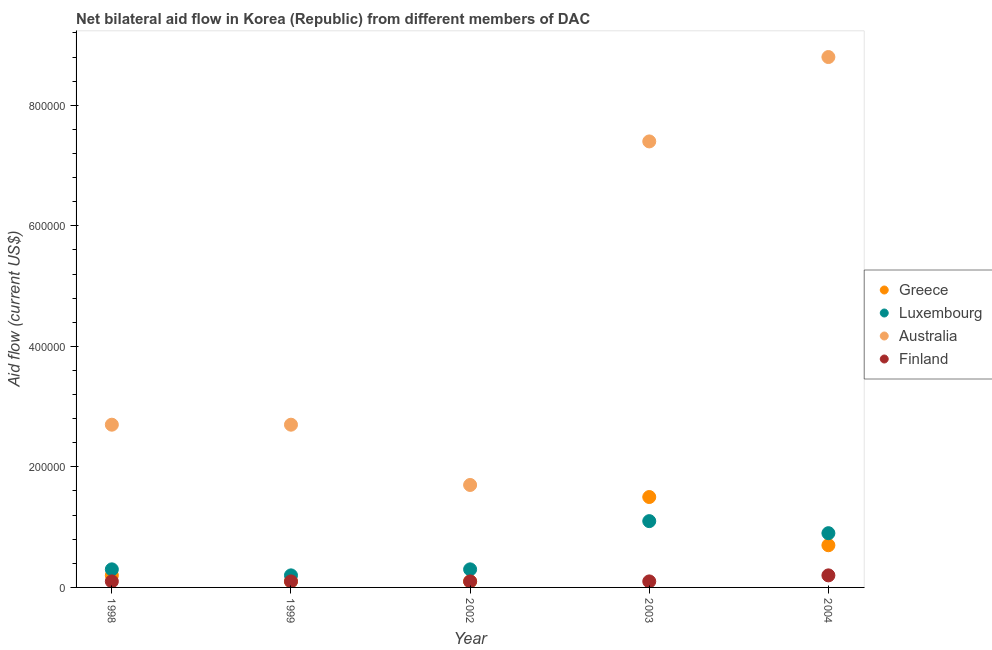How many different coloured dotlines are there?
Offer a very short reply. 4. Is the number of dotlines equal to the number of legend labels?
Keep it short and to the point. Yes. What is the amount of aid given by finland in 2004?
Offer a very short reply. 2.00e+04. Across all years, what is the maximum amount of aid given by luxembourg?
Provide a short and direct response. 1.10e+05. Across all years, what is the minimum amount of aid given by luxembourg?
Your answer should be compact. 2.00e+04. In which year was the amount of aid given by finland minimum?
Your answer should be very brief. 1998. What is the total amount of aid given by australia in the graph?
Make the answer very short. 2.33e+06. What is the difference between the amount of aid given by finland in 1998 and that in 2003?
Provide a short and direct response. 0. What is the difference between the amount of aid given by greece in 2002 and the amount of aid given by finland in 2004?
Provide a short and direct response. -10000. What is the average amount of aid given by luxembourg per year?
Your answer should be compact. 5.60e+04. In the year 2004, what is the difference between the amount of aid given by greece and amount of aid given by australia?
Your answer should be compact. -8.10e+05. What is the ratio of the amount of aid given by greece in 2003 to that in 2004?
Make the answer very short. 2.14. Is the amount of aid given by luxembourg in 1999 less than that in 2002?
Make the answer very short. Yes. What is the difference between the highest and the second highest amount of aid given by greece?
Your response must be concise. 8.00e+04. What is the difference between the highest and the lowest amount of aid given by australia?
Your answer should be very brief. 7.10e+05. Is it the case that in every year, the sum of the amount of aid given by greece and amount of aid given by luxembourg is greater than the amount of aid given by australia?
Your answer should be very brief. No. Does the amount of aid given by greece monotonically increase over the years?
Make the answer very short. No. Is the amount of aid given by greece strictly greater than the amount of aid given by luxembourg over the years?
Your answer should be compact. No. Is the amount of aid given by australia strictly less than the amount of aid given by luxembourg over the years?
Provide a short and direct response. No. What is the difference between two consecutive major ticks on the Y-axis?
Your response must be concise. 2.00e+05. Are the values on the major ticks of Y-axis written in scientific E-notation?
Offer a terse response. No. Does the graph contain grids?
Offer a terse response. No. Where does the legend appear in the graph?
Keep it short and to the point. Center right. What is the title of the graph?
Your answer should be very brief. Net bilateral aid flow in Korea (Republic) from different members of DAC. Does "Miscellaneous expenses" appear as one of the legend labels in the graph?
Make the answer very short. No. What is the label or title of the X-axis?
Keep it short and to the point. Year. What is the Aid flow (current US$) in Finland in 1998?
Provide a short and direct response. 10000. What is the Aid flow (current US$) of Luxembourg in 1999?
Ensure brevity in your answer.  2.00e+04. What is the Aid flow (current US$) of Australia in 1999?
Your response must be concise. 2.70e+05. What is the Aid flow (current US$) in Finland in 1999?
Offer a very short reply. 10000. What is the Aid flow (current US$) in Luxembourg in 2002?
Give a very brief answer. 3.00e+04. What is the Aid flow (current US$) of Australia in 2002?
Keep it short and to the point. 1.70e+05. What is the Aid flow (current US$) in Australia in 2003?
Give a very brief answer. 7.40e+05. What is the Aid flow (current US$) in Finland in 2003?
Your answer should be very brief. 10000. What is the Aid flow (current US$) of Greece in 2004?
Provide a short and direct response. 7.00e+04. What is the Aid flow (current US$) of Luxembourg in 2004?
Your response must be concise. 9.00e+04. What is the Aid flow (current US$) of Australia in 2004?
Your answer should be very brief. 8.80e+05. What is the Aid flow (current US$) of Finland in 2004?
Ensure brevity in your answer.  2.00e+04. Across all years, what is the maximum Aid flow (current US$) of Greece?
Offer a terse response. 1.50e+05. Across all years, what is the maximum Aid flow (current US$) of Luxembourg?
Provide a short and direct response. 1.10e+05. Across all years, what is the maximum Aid flow (current US$) of Australia?
Offer a terse response. 8.80e+05. Across all years, what is the minimum Aid flow (current US$) in Greece?
Your answer should be very brief. 10000. Across all years, what is the minimum Aid flow (current US$) in Luxembourg?
Make the answer very short. 2.00e+04. What is the total Aid flow (current US$) in Luxembourg in the graph?
Provide a short and direct response. 2.80e+05. What is the total Aid flow (current US$) of Australia in the graph?
Make the answer very short. 2.33e+06. What is the difference between the Aid flow (current US$) of Luxembourg in 1998 and that in 1999?
Ensure brevity in your answer.  10000. What is the difference between the Aid flow (current US$) in Australia in 1998 and that in 1999?
Your answer should be compact. 0. What is the difference between the Aid flow (current US$) of Australia in 1998 and that in 2002?
Make the answer very short. 1.00e+05. What is the difference between the Aid flow (current US$) of Luxembourg in 1998 and that in 2003?
Give a very brief answer. -8.00e+04. What is the difference between the Aid flow (current US$) in Australia in 1998 and that in 2003?
Give a very brief answer. -4.70e+05. What is the difference between the Aid flow (current US$) in Greece in 1998 and that in 2004?
Provide a succinct answer. -5.00e+04. What is the difference between the Aid flow (current US$) of Australia in 1998 and that in 2004?
Offer a very short reply. -6.10e+05. What is the difference between the Aid flow (current US$) in Greece in 1999 and that in 2002?
Keep it short and to the point. 0. What is the difference between the Aid flow (current US$) in Luxembourg in 1999 and that in 2002?
Provide a short and direct response. -10000. What is the difference between the Aid flow (current US$) in Australia in 1999 and that in 2002?
Make the answer very short. 1.00e+05. What is the difference between the Aid flow (current US$) in Finland in 1999 and that in 2002?
Give a very brief answer. 0. What is the difference between the Aid flow (current US$) of Greece in 1999 and that in 2003?
Offer a terse response. -1.40e+05. What is the difference between the Aid flow (current US$) of Luxembourg in 1999 and that in 2003?
Provide a succinct answer. -9.00e+04. What is the difference between the Aid flow (current US$) of Australia in 1999 and that in 2003?
Offer a very short reply. -4.70e+05. What is the difference between the Aid flow (current US$) in Greece in 1999 and that in 2004?
Offer a terse response. -6.00e+04. What is the difference between the Aid flow (current US$) in Australia in 1999 and that in 2004?
Provide a short and direct response. -6.10e+05. What is the difference between the Aid flow (current US$) in Finland in 1999 and that in 2004?
Offer a terse response. -10000. What is the difference between the Aid flow (current US$) of Luxembourg in 2002 and that in 2003?
Your answer should be very brief. -8.00e+04. What is the difference between the Aid flow (current US$) in Australia in 2002 and that in 2003?
Your answer should be very brief. -5.70e+05. What is the difference between the Aid flow (current US$) of Luxembourg in 2002 and that in 2004?
Offer a terse response. -6.00e+04. What is the difference between the Aid flow (current US$) of Australia in 2002 and that in 2004?
Make the answer very short. -7.10e+05. What is the difference between the Aid flow (current US$) of Finland in 2002 and that in 2004?
Keep it short and to the point. -10000. What is the difference between the Aid flow (current US$) in Greece in 2003 and that in 2004?
Make the answer very short. 8.00e+04. What is the difference between the Aid flow (current US$) of Luxembourg in 2003 and that in 2004?
Provide a short and direct response. 2.00e+04. What is the difference between the Aid flow (current US$) of Finland in 2003 and that in 2004?
Provide a short and direct response. -10000. What is the difference between the Aid flow (current US$) in Greece in 1998 and the Aid flow (current US$) in Luxembourg in 1999?
Provide a short and direct response. 0. What is the difference between the Aid flow (current US$) in Greece in 1998 and the Aid flow (current US$) in Australia in 1999?
Your answer should be compact. -2.50e+05. What is the difference between the Aid flow (current US$) in Greece in 1998 and the Aid flow (current US$) in Finland in 1999?
Keep it short and to the point. 10000. What is the difference between the Aid flow (current US$) in Luxembourg in 1998 and the Aid flow (current US$) in Australia in 1999?
Make the answer very short. -2.40e+05. What is the difference between the Aid flow (current US$) of Luxembourg in 1998 and the Aid flow (current US$) of Finland in 1999?
Make the answer very short. 2.00e+04. What is the difference between the Aid flow (current US$) of Australia in 1998 and the Aid flow (current US$) of Finland in 1999?
Make the answer very short. 2.60e+05. What is the difference between the Aid flow (current US$) in Greece in 1998 and the Aid flow (current US$) in Luxembourg in 2002?
Make the answer very short. -10000. What is the difference between the Aid flow (current US$) in Greece in 1998 and the Aid flow (current US$) in Finland in 2002?
Provide a succinct answer. 10000. What is the difference between the Aid flow (current US$) of Luxembourg in 1998 and the Aid flow (current US$) of Australia in 2002?
Your answer should be compact. -1.40e+05. What is the difference between the Aid flow (current US$) in Luxembourg in 1998 and the Aid flow (current US$) in Finland in 2002?
Provide a short and direct response. 2.00e+04. What is the difference between the Aid flow (current US$) of Greece in 1998 and the Aid flow (current US$) of Australia in 2003?
Keep it short and to the point. -7.20e+05. What is the difference between the Aid flow (current US$) of Luxembourg in 1998 and the Aid flow (current US$) of Australia in 2003?
Give a very brief answer. -7.10e+05. What is the difference between the Aid flow (current US$) of Australia in 1998 and the Aid flow (current US$) of Finland in 2003?
Offer a terse response. 2.60e+05. What is the difference between the Aid flow (current US$) in Greece in 1998 and the Aid flow (current US$) in Luxembourg in 2004?
Your response must be concise. -7.00e+04. What is the difference between the Aid flow (current US$) in Greece in 1998 and the Aid flow (current US$) in Australia in 2004?
Provide a succinct answer. -8.60e+05. What is the difference between the Aid flow (current US$) of Greece in 1998 and the Aid flow (current US$) of Finland in 2004?
Give a very brief answer. 0. What is the difference between the Aid flow (current US$) of Luxembourg in 1998 and the Aid flow (current US$) of Australia in 2004?
Offer a very short reply. -8.50e+05. What is the difference between the Aid flow (current US$) of Luxembourg in 1998 and the Aid flow (current US$) of Finland in 2004?
Offer a very short reply. 10000. What is the difference between the Aid flow (current US$) of Australia in 1998 and the Aid flow (current US$) of Finland in 2004?
Your answer should be compact. 2.50e+05. What is the difference between the Aid flow (current US$) of Greece in 1999 and the Aid flow (current US$) of Luxembourg in 2002?
Ensure brevity in your answer.  -2.00e+04. What is the difference between the Aid flow (current US$) in Greece in 1999 and the Aid flow (current US$) in Australia in 2002?
Your response must be concise. -1.60e+05. What is the difference between the Aid flow (current US$) of Luxembourg in 1999 and the Aid flow (current US$) of Finland in 2002?
Your answer should be compact. 10000. What is the difference between the Aid flow (current US$) in Greece in 1999 and the Aid flow (current US$) in Luxembourg in 2003?
Your answer should be compact. -1.00e+05. What is the difference between the Aid flow (current US$) in Greece in 1999 and the Aid flow (current US$) in Australia in 2003?
Offer a very short reply. -7.30e+05. What is the difference between the Aid flow (current US$) in Greece in 1999 and the Aid flow (current US$) in Finland in 2003?
Offer a terse response. 0. What is the difference between the Aid flow (current US$) of Luxembourg in 1999 and the Aid flow (current US$) of Australia in 2003?
Provide a short and direct response. -7.20e+05. What is the difference between the Aid flow (current US$) in Greece in 1999 and the Aid flow (current US$) in Luxembourg in 2004?
Provide a short and direct response. -8.00e+04. What is the difference between the Aid flow (current US$) of Greece in 1999 and the Aid flow (current US$) of Australia in 2004?
Ensure brevity in your answer.  -8.70e+05. What is the difference between the Aid flow (current US$) of Luxembourg in 1999 and the Aid flow (current US$) of Australia in 2004?
Provide a succinct answer. -8.60e+05. What is the difference between the Aid flow (current US$) of Greece in 2002 and the Aid flow (current US$) of Australia in 2003?
Make the answer very short. -7.30e+05. What is the difference between the Aid flow (current US$) of Greece in 2002 and the Aid flow (current US$) of Finland in 2003?
Provide a succinct answer. 0. What is the difference between the Aid flow (current US$) of Luxembourg in 2002 and the Aid flow (current US$) of Australia in 2003?
Ensure brevity in your answer.  -7.10e+05. What is the difference between the Aid flow (current US$) in Luxembourg in 2002 and the Aid flow (current US$) in Finland in 2003?
Offer a very short reply. 2.00e+04. What is the difference between the Aid flow (current US$) in Greece in 2002 and the Aid flow (current US$) in Luxembourg in 2004?
Provide a short and direct response. -8.00e+04. What is the difference between the Aid flow (current US$) of Greece in 2002 and the Aid flow (current US$) of Australia in 2004?
Offer a very short reply. -8.70e+05. What is the difference between the Aid flow (current US$) of Greece in 2002 and the Aid flow (current US$) of Finland in 2004?
Provide a short and direct response. -10000. What is the difference between the Aid flow (current US$) of Luxembourg in 2002 and the Aid flow (current US$) of Australia in 2004?
Keep it short and to the point. -8.50e+05. What is the difference between the Aid flow (current US$) of Greece in 2003 and the Aid flow (current US$) of Luxembourg in 2004?
Keep it short and to the point. 6.00e+04. What is the difference between the Aid flow (current US$) in Greece in 2003 and the Aid flow (current US$) in Australia in 2004?
Your answer should be compact. -7.30e+05. What is the difference between the Aid flow (current US$) of Greece in 2003 and the Aid flow (current US$) of Finland in 2004?
Provide a succinct answer. 1.30e+05. What is the difference between the Aid flow (current US$) of Luxembourg in 2003 and the Aid flow (current US$) of Australia in 2004?
Provide a succinct answer. -7.70e+05. What is the difference between the Aid flow (current US$) of Australia in 2003 and the Aid flow (current US$) of Finland in 2004?
Keep it short and to the point. 7.20e+05. What is the average Aid flow (current US$) of Greece per year?
Your answer should be very brief. 5.20e+04. What is the average Aid flow (current US$) in Luxembourg per year?
Your answer should be compact. 5.60e+04. What is the average Aid flow (current US$) in Australia per year?
Keep it short and to the point. 4.66e+05. What is the average Aid flow (current US$) of Finland per year?
Your answer should be compact. 1.20e+04. In the year 1998, what is the difference between the Aid flow (current US$) in Greece and Aid flow (current US$) in Luxembourg?
Your answer should be compact. -10000. In the year 1998, what is the difference between the Aid flow (current US$) of Greece and Aid flow (current US$) of Finland?
Your response must be concise. 10000. In the year 1998, what is the difference between the Aid flow (current US$) of Luxembourg and Aid flow (current US$) of Finland?
Offer a terse response. 2.00e+04. In the year 2002, what is the difference between the Aid flow (current US$) in Greece and Aid flow (current US$) in Luxembourg?
Offer a terse response. -2.00e+04. In the year 2002, what is the difference between the Aid flow (current US$) in Australia and Aid flow (current US$) in Finland?
Your answer should be compact. 1.60e+05. In the year 2003, what is the difference between the Aid flow (current US$) in Greece and Aid flow (current US$) in Australia?
Provide a short and direct response. -5.90e+05. In the year 2003, what is the difference between the Aid flow (current US$) of Luxembourg and Aid flow (current US$) of Australia?
Your answer should be compact. -6.30e+05. In the year 2003, what is the difference between the Aid flow (current US$) of Australia and Aid flow (current US$) of Finland?
Offer a very short reply. 7.30e+05. In the year 2004, what is the difference between the Aid flow (current US$) of Greece and Aid flow (current US$) of Luxembourg?
Ensure brevity in your answer.  -2.00e+04. In the year 2004, what is the difference between the Aid flow (current US$) in Greece and Aid flow (current US$) in Australia?
Make the answer very short. -8.10e+05. In the year 2004, what is the difference between the Aid flow (current US$) in Greece and Aid flow (current US$) in Finland?
Your answer should be very brief. 5.00e+04. In the year 2004, what is the difference between the Aid flow (current US$) of Luxembourg and Aid flow (current US$) of Australia?
Ensure brevity in your answer.  -7.90e+05. In the year 2004, what is the difference between the Aid flow (current US$) of Luxembourg and Aid flow (current US$) of Finland?
Your answer should be compact. 7.00e+04. In the year 2004, what is the difference between the Aid flow (current US$) of Australia and Aid flow (current US$) of Finland?
Your answer should be very brief. 8.60e+05. What is the ratio of the Aid flow (current US$) in Australia in 1998 to that in 1999?
Provide a short and direct response. 1. What is the ratio of the Aid flow (current US$) in Luxembourg in 1998 to that in 2002?
Provide a succinct answer. 1. What is the ratio of the Aid flow (current US$) in Australia in 1998 to that in 2002?
Ensure brevity in your answer.  1.59. What is the ratio of the Aid flow (current US$) of Finland in 1998 to that in 2002?
Your response must be concise. 1. What is the ratio of the Aid flow (current US$) of Greece in 1998 to that in 2003?
Your answer should be compact. 0.13. What is the ratio of the Aid flow (current US$) in Luxembourg in 1998 to that in 2003?
Provide a succinct answer. 0.27. What is the ratio of the Aid flow (current US$) in Australia in 1998 to that in 2003?
Offer a very short reply. 0.36. What is the ratio of the Aid flow (current US$) in Greece in 1998 to that in 2004?
Make the answer very short. 0.29. What is the ratio of the Aid flow (current US$) in Australia in 1998 to that in 2004?
Ensure brevity in your answer.  0.31. What is the ratio of the Aid flow (current US$) in Finland in 1998 to that in 2004?
Offer a terse response. 0.5. What is the ratio of the Aid flow (current US$) in Greece in 1999 to that in 2002?
Ensure brevity in your answer.  1. What is the ratio of the Aid flow (current US$) in Australia in 1999 to that in 2002?
Your answer should be very brief. 1.59. What is the ratio of the Aid flow (current US$) of Greece in 1999 to that in 2003?
Offer a very short reply. 0.07. What is the ratio of the Aid flow (current US$) in Luxembourg in 1999 to that in 2003?
Your answer should be compact. 0.18. What is the ratio of the Aid flow (current US$) of Australia in 1999 to that in 2003?
Your answer should be very brief. 0.36. What is the ratio of the Aid flow (current US$) of Finland in 1999 to that in 2003?
Offer a very short reply. 1. What is the ratio of the Aid flow (current US$) in Greece in 1999 to that in 2004?
Give a very brief answer. 0.14. What is the ratio of the Aid flow (current US$) of Luxembourg in 1999 to that in 2004?
Provide a short and direct response. 0.22. What is the ratio of the Aid flow (current US$) in Australia in 1999 to that in 2004?
Provide a short and direct response. 0.31. What is the ratio of the Aid flow (current US$) in Finland in 1999 to that in 2004?
Provide a short and direct response. 0.5. What is the ratio of the Aid flow (current US$) in Greece in 2002 to that in 2003?
Your answer should be compact. 0.07. What is the ratio of the Aid flow (current US$) in Luxembourg in 2002 to that in 2003?
Offer a very short reply. 0.27. What is the ratio of the Aid flow (current US$) of Australia in 2002 to that in 2003?
Provide a succinct answer. 0.23. What is the ratio of the Aid flow (current US$) of Finland in 2002 to that in 2003?
Give a very brief answer. 1. What is the ratio of the Aid flow (current US$) in Greece in 2002 to that in 2004?
Offer a terse response. 0.14. What is the ratio of the Aid flow (current US$) of Australia in 2002 to that in 2004?
Keep it short and to the point. 0.19. What is the ratio of the Aid flow (current US$) in Finland in 2002 to that in 2004?
Your response must be concise. 0.5. What is the ratio of the Aid flow (current US$) of Greece in 2003 to that in 2004?
Ensure brevity in your answer.  2.14. What is the ratio of the Aid flow (current US$) in Luxembourg in 2003 to that in 2004?
Ensure brevity in your answer.  1.22. What is the ratio of the Aid flow (current US$) of Australia in 2003 to that in 2004?
Give a very brief answer. 0.84. What is the difference between the highest and the second highest Aid flow (current US$) in Australia?
Ensure brevity in your answer.  1.40e+05. What is the difference between the highest and the second highest Aid flow (current US$) of Finland?
Your answer should be compact. 10000. What is the difference between the highest and the lowest Aid flow (current US$) in Luxembourg?
Provide a succinct answer. 9.00e+04. What is the difference between the highest and the lowest Aid flow (current US$) of Australia?
Your answer should be very brief. 7.10e+05. What is the difference between the highest and the lowest Aid flow (current US$) in Finland?
Your answer should be compact. 10000. 